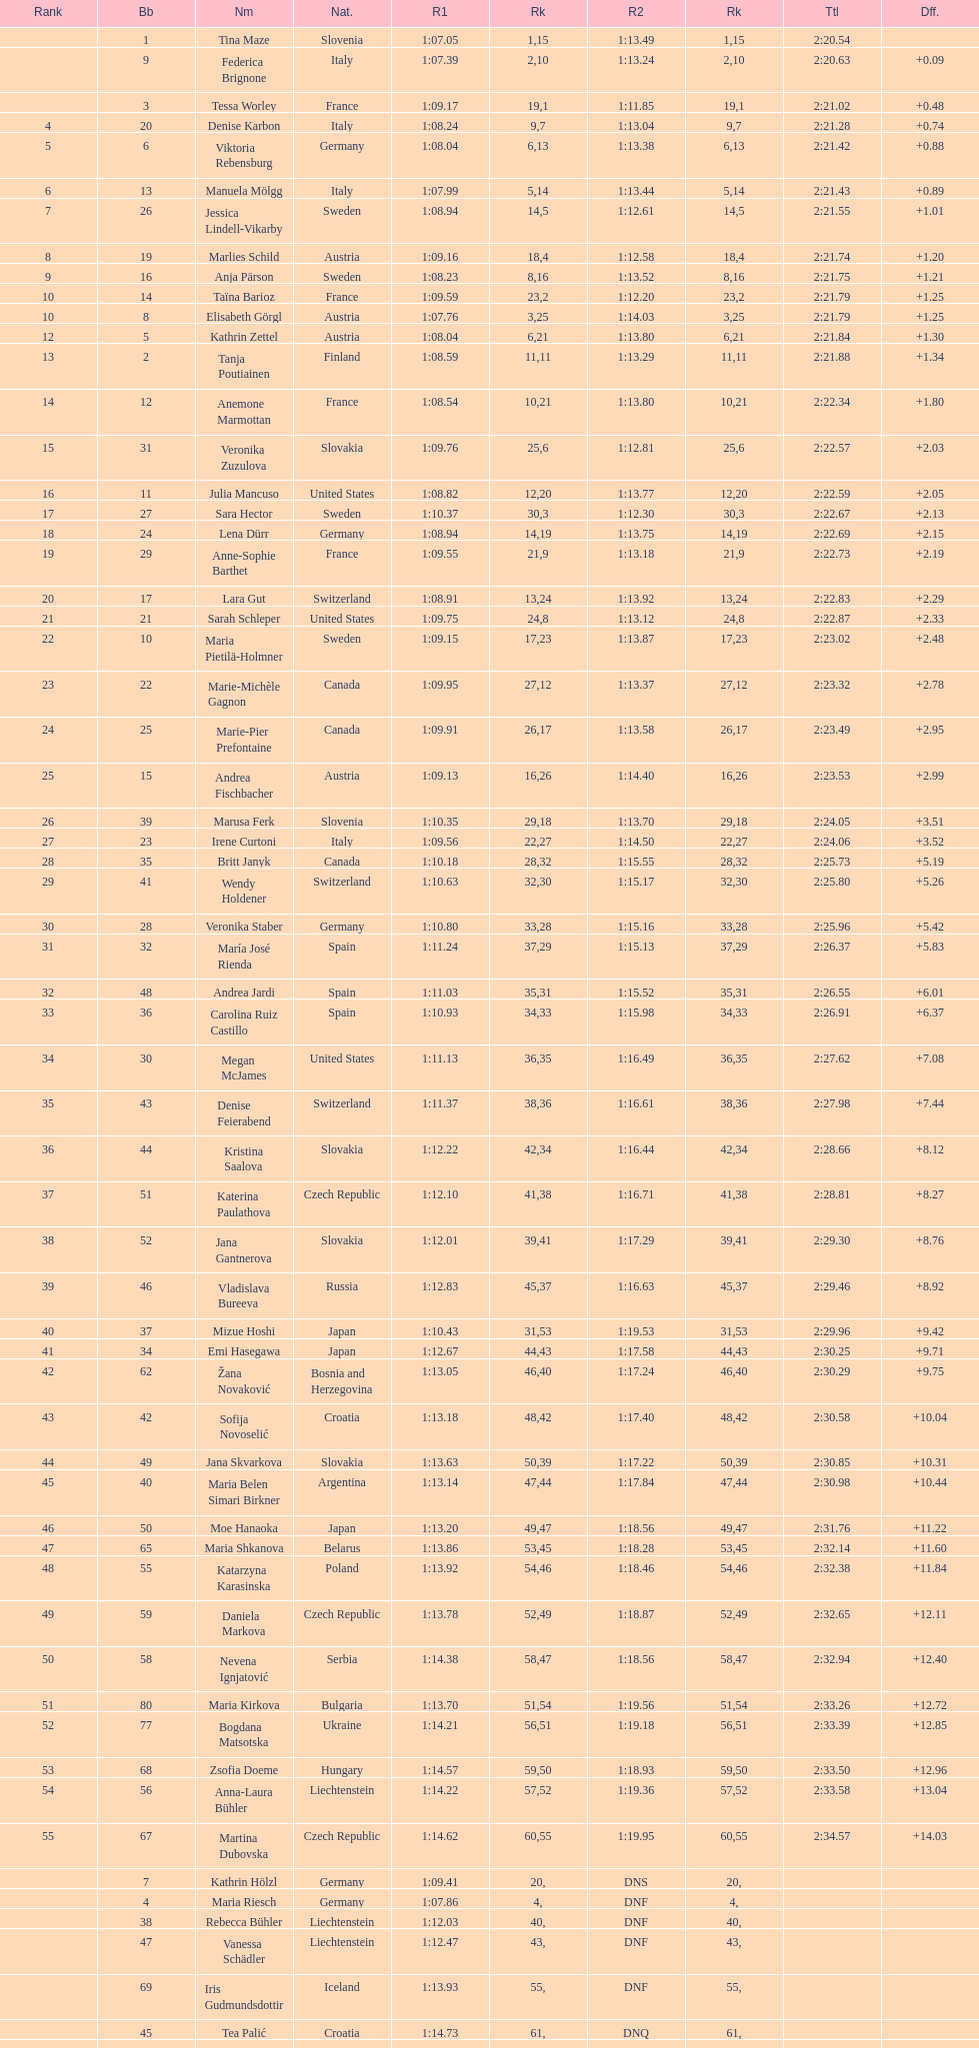Who finished next after federica brignone? Tessa Worley. 